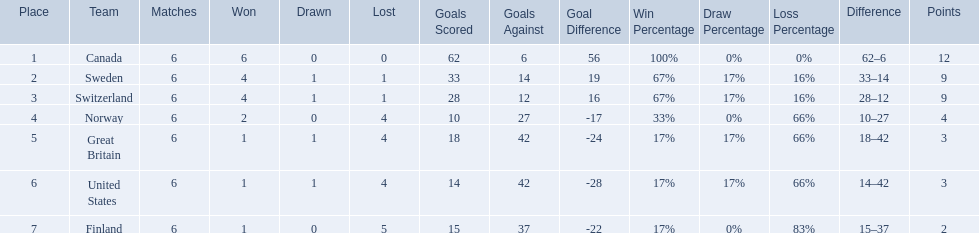What are the names of the countries? Canada, Sweden, Switzerland, Norway, Great Britain, United States, Finland. How many wins did switzerland have? 4. How many wins did great britain have? 1. Which country had more wins, great britain or switzerland? Switzerland. 